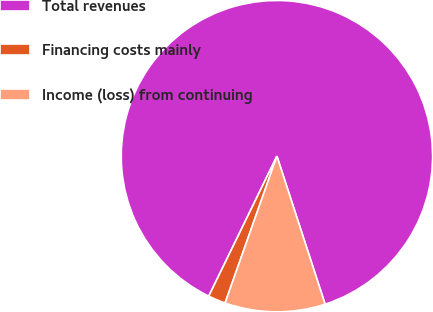<chart> <loc_0><loc_0><loc_500><loc_500><pie_chart><fcel>Total revenues<fcel>Financing costs mainly<fcel>Income (loss) from continuing<nl><fcel>87.78%<fcel>1.81%<fcel>10.41%<nl></chart> 